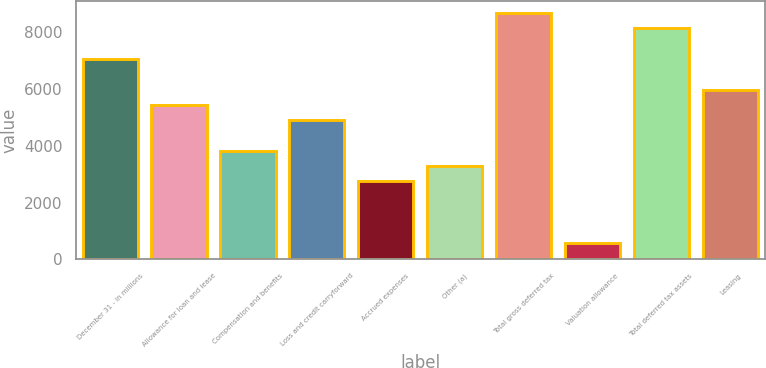Convert chart to OTSL. <chart><loc_0><loc_0><loc_500><loc_500><bar_chart><fcel>December 31 - in millions<fcel>Allowance for loan and lease<fcel>Compensation and benefits<fcel>Loss and credit carryforward<fcel>Accrued expenses<fcel>Other (a)<fcel>Total gross deferred tax<fcel>Valuation allowance<fcel>Total deferred tax assets<fcel>Leasing<nl><fcel>7053.7<fcel>5437<fcel>3820.3<fcel>4898.1<fcel>2742.5<fcel>3281.4<fcel>8670.4<fcel>586.9<fcel>8131.5<fcel>5975.9<nl></chart> 